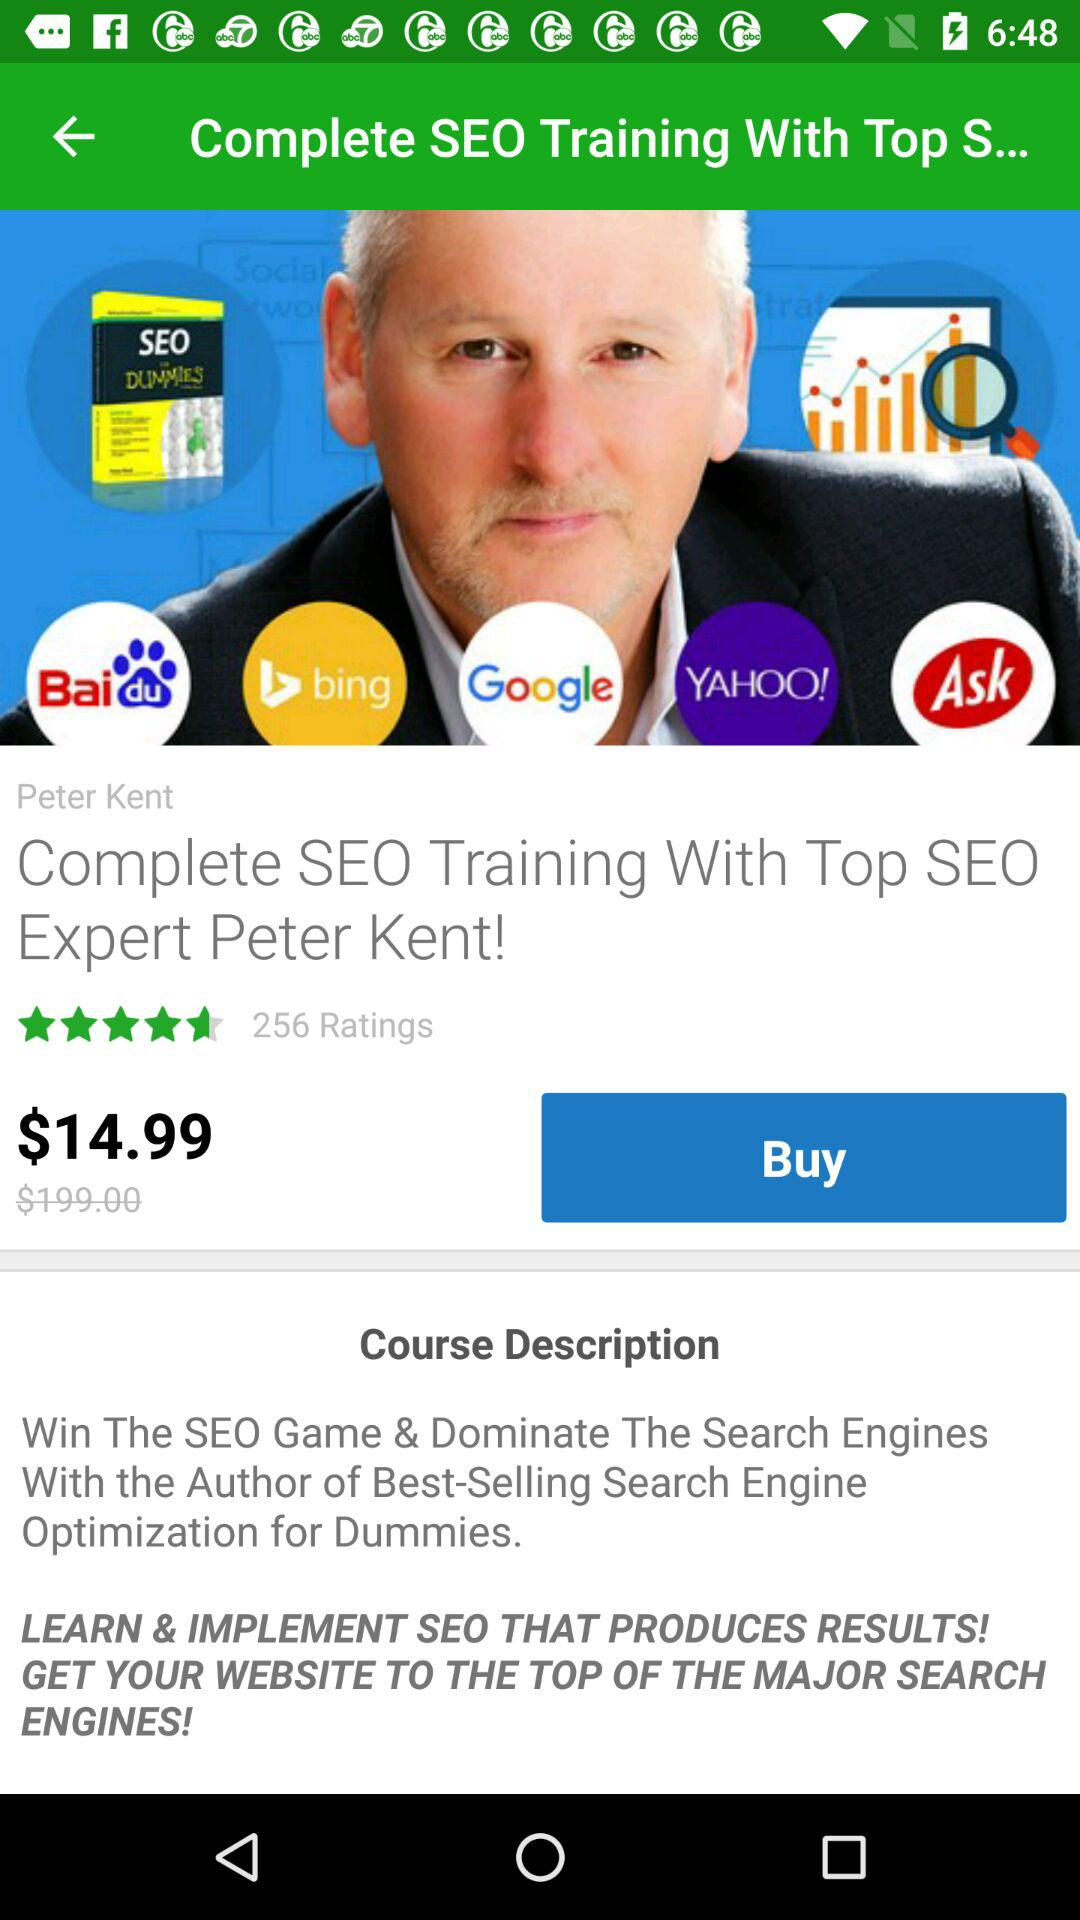What training has been provided in the course? The training that has been provided in the course is on SEO. 